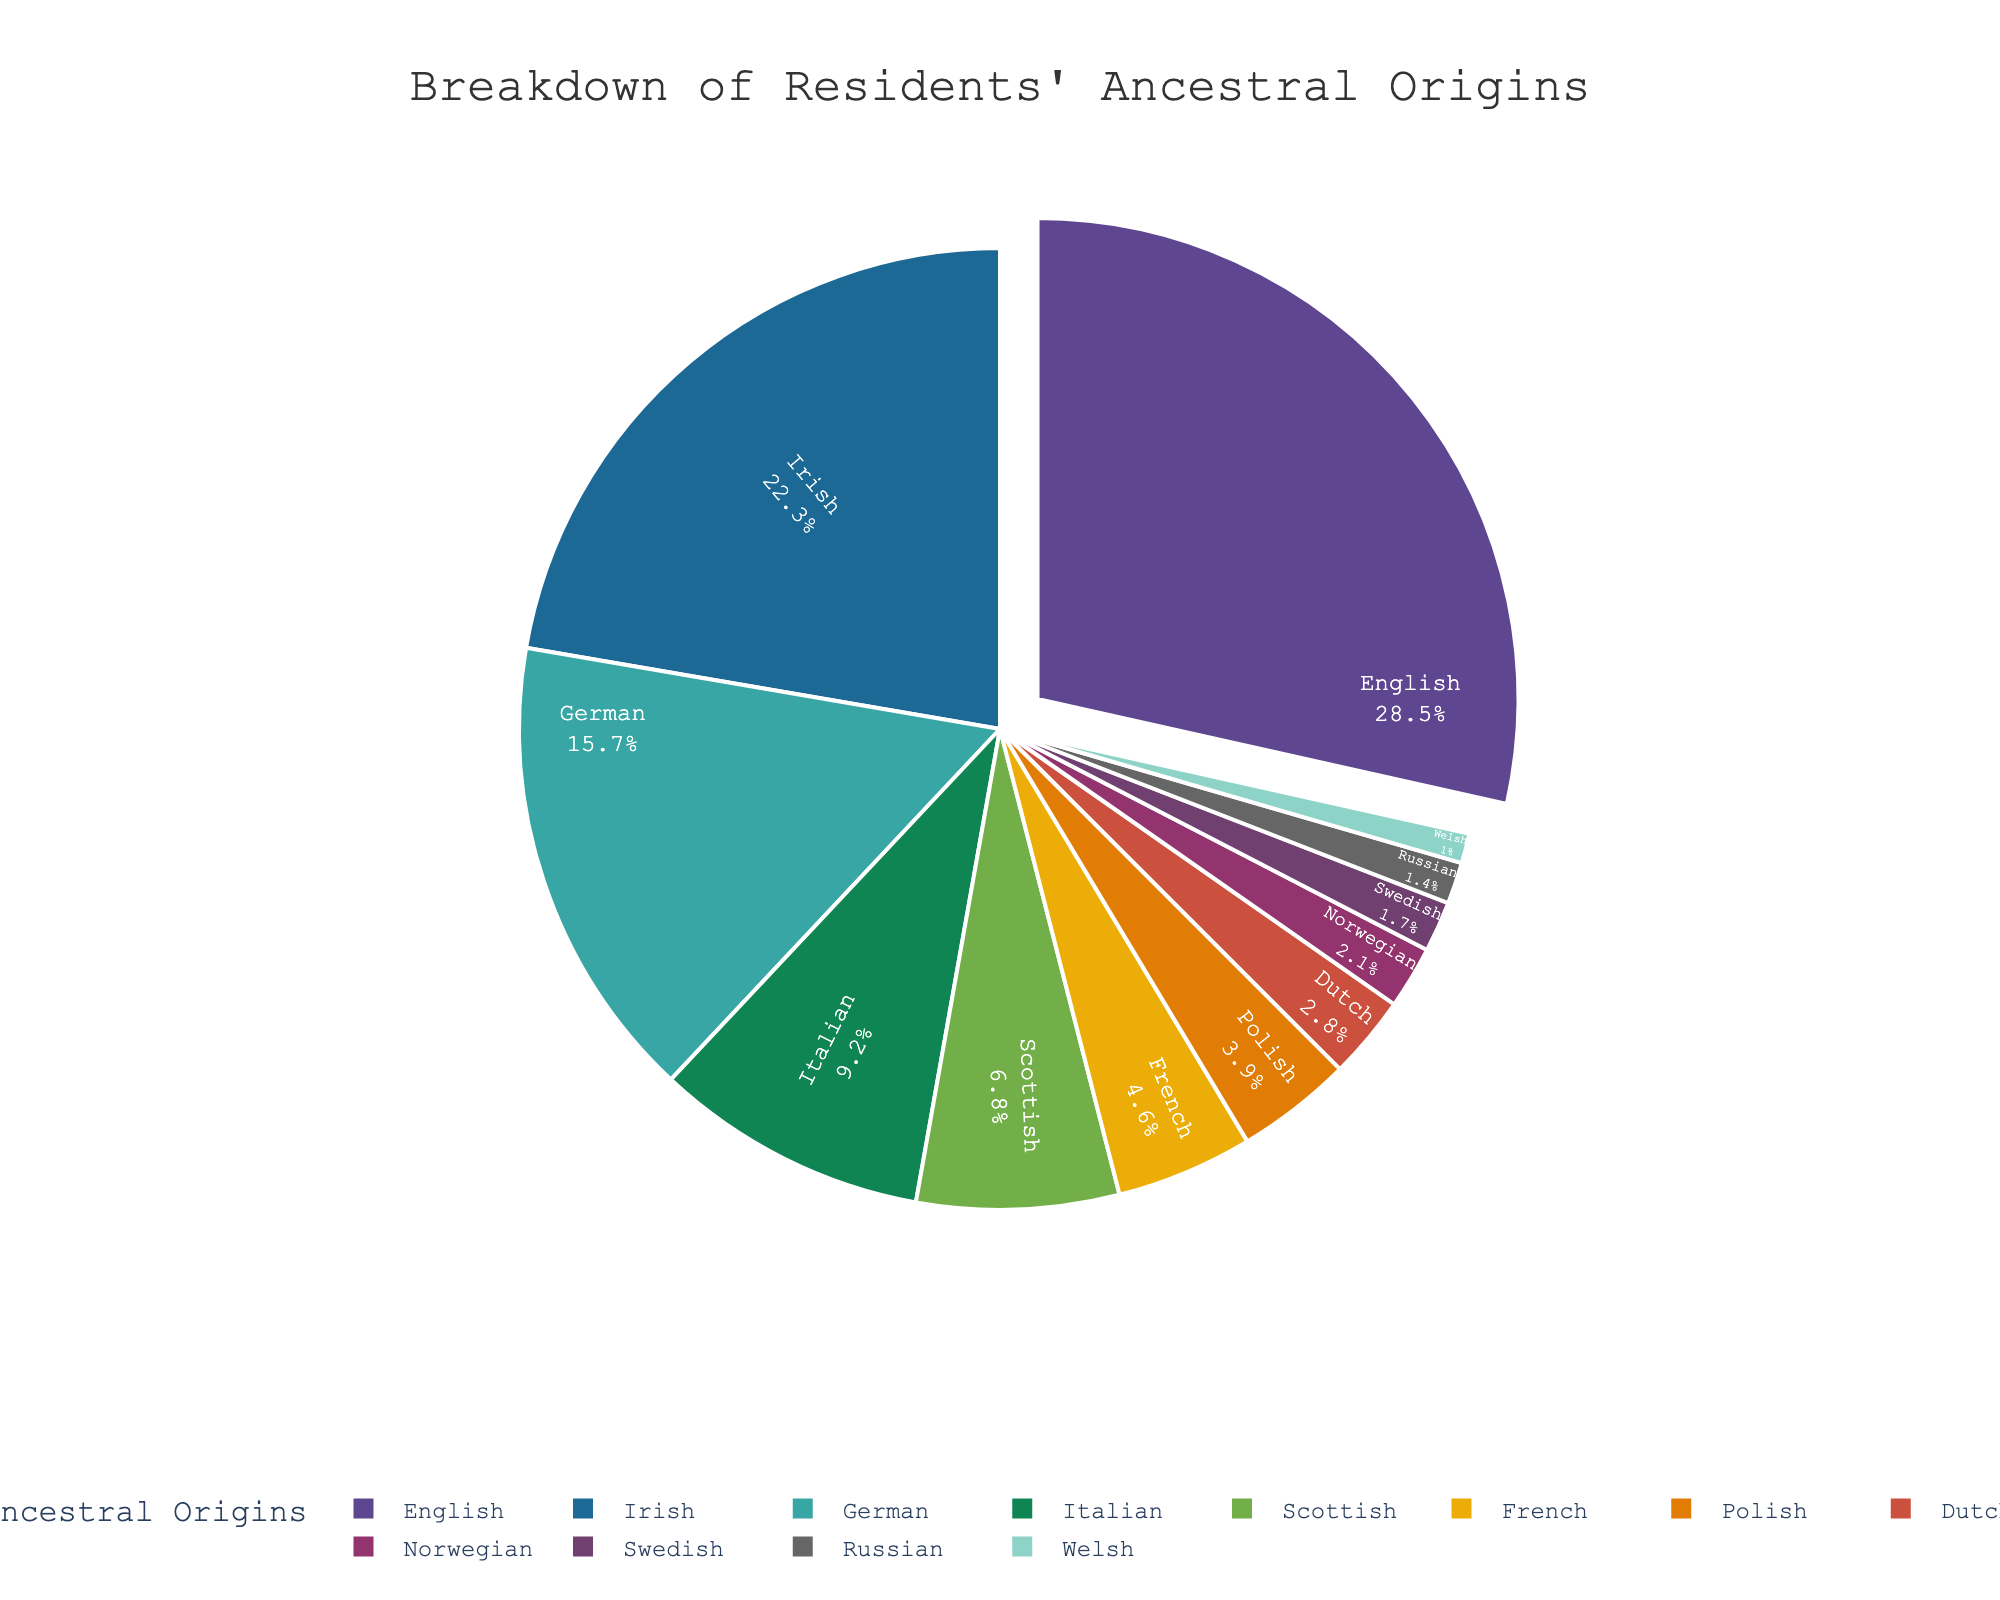Which ancestral origin has the highest percentage? The pie chart shows the share of each ancestral origin. By looking at the sizes of the slices, we see that the slice labeled "English" is the largest.
Answer: English Which ancestral origin has the smallest percentage? The smallest slice in the pie chart is labeled "Welsh," indicating it has the smallest percentage.
Answer: Welsh What is the total percentage of residents with German and Italian origins combined? To find the combined percentage, add the percentages for German (15.7%) and Italian (9.2%): 15.7 + 9.2 = 24.9.
Answer: 24.9 Are there more residents of Irish or Scottish origin? Comparing the slices for Irish and Scottish, the Irish slice is larger, indicating a higher percentage of residents with Irish origin.
Answer: Irish How much larger is the percentage of English origin compared to Polish origin? Subtract the percentage of Polish origin (3.9%) from the percentage of English origin (28.5%): 28.5 - 3.9 = 24.6.
Answer: 24.6 What is the combined percentage of residents with Norwegian, Swedish, and Russian origins? Add the percentages of Norwegian (2.1%), Swedish (1.7%), and Russian (1.4%): 2.1 + 1.7 + 1.4 = 5.2.
Answer: 5.2 Rank the top three ancestral origins in descending order. The top three ancestral origins are the ones with the largest percentages. By observation, they are English (28.5%), Irish (22.3%), and German (15.7%).
Answer: English, Irish, German By how much does the percentage of residents with German origin exceed the percentage of those with French origin? Subtract the percentage of French origin (4.6%) from the percentage of German origin (15.7%): 15.7 - 4.6 = 11.1.
Answer: 11.1 If the residents with Irish and Scottish origins were combined into a single category, what percentage would this new category represent? Add the percentages for Irish (22.3%) and Scottish (6.8%): 22.3 + 6.8 = 29.1.
Answer: 29.1 Is the percentage of residents with Italian origin more than twice the percentage of those with Dutch origin? The percentage for Italian origin (9.2%) compared to twice the percentage for Dutch origin (2.8%) is 9.2 vs. 2*2.8 = 5.6, meaning 9.2 > 5.6.
Answer: Yes 